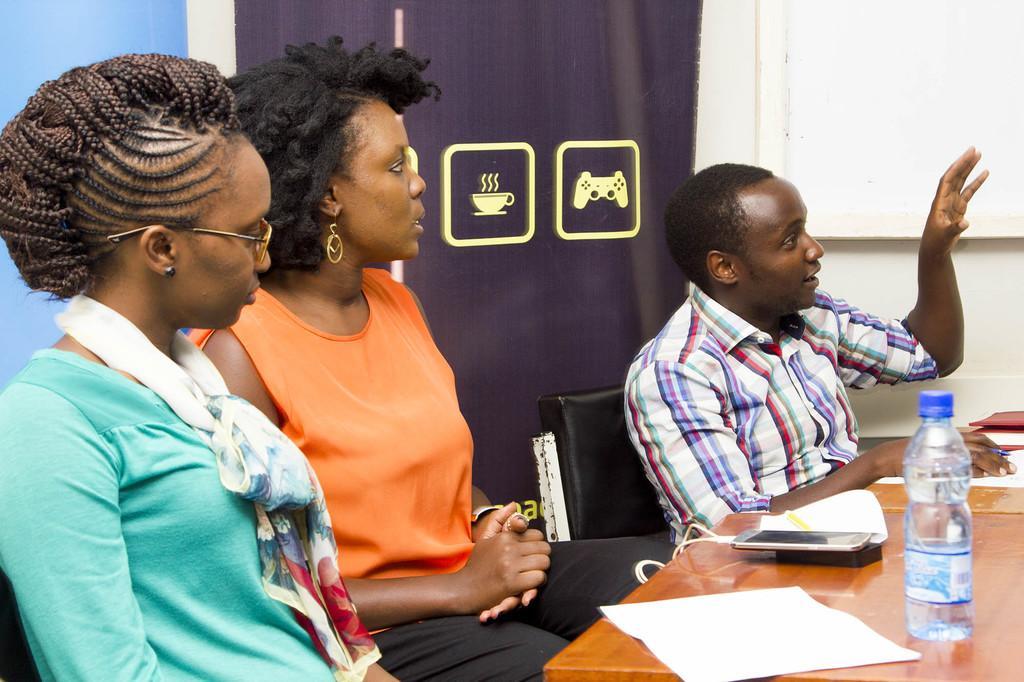Can you describe this image briefly? I can see in this image two women and a man is sitting on a chair in front of a table. On the table I can see a bottle and other objects on it. 